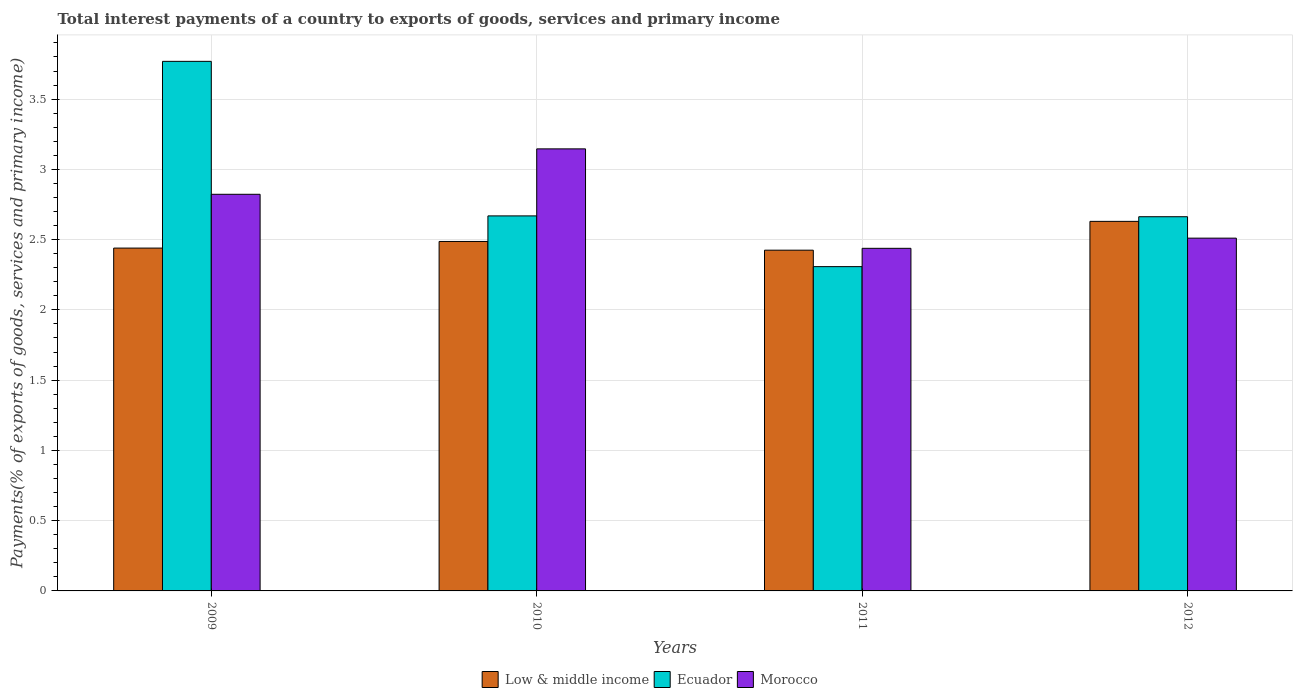Are the number of bars on each tick of the X-axis equal?
Offer a very short reply. Yes. In how many cases, is the number of bars for a given year not equal to the number of legend labels?
Ensure brevity in your answer.  0. What is the total interest payments in Ecuador in 2009?
Provide a short and direct response. 3.77. Across all years, what is the maximum total interest payments in Low & middle income?
Offer a terse response. 2.63. Across all years, what is the minimum total interest payments in Low & middle income?
Provide a short and direct response. 2.42. In which year was the total interest payments in Morocco minimum?
Provide a succinct answer. 2011. What is the total total interest payments in Low & middle income in the graph?
Your answer should be very brief. 9.98. What is the difference between the total interest payments in Morocco in 2011 and that in 2012?
Your answer should be compact. -0.07. What is the difference between the total interest payments in Ecuador in 2011 and the total interest payments in Morocco in 2012?
Your response must be concise. -0.2. What is the average total interest payments in Ecuador per year?
Your response must be concise. 2.85. In the year 2011, what is the difference between the total interest payments in Ecuador and total interest payments in Morocco?
Provide a short and direct response. -0.13. What is the ratio of the total interest payments in Ecuador in 2009 to that in 2012?
Your answer should be very brief. 1.42. Is the difference between the total interest payments in Ecuador in 2009 and 2012 greater than the difference between the total interest payments in Morocco in 2009 and 2012?
Provide a succinct answer. Yes. What is the difference between the highest and the second highest total interest payments in Ecuador?
Ensure brevity in your answer.  1.1. What is the difference between the highest and the lowest total interest payments in Ecuador?
Ensure brevity in your answer.  1.46. In how many years, is the total interest payments in Ecuador greater than the average total interest payments in Ecuador taken over all years?
Offer a very short reply. 1. What does the 2nd bar from the left in 2009 represents?
Provide a succinct answer. Ecuador. What does the 1st bar from the right in 2009 represents?
Provide a short and direct response. Morocco. How many years are there in the graph?
Your answer should be compact. 4. Are the values on the major ticks of Y-axis written in scientific E-notation?
Your answer should be very brief. No. Where does the legend appear in the graph?
Your answer should be very brief. Bottom center. What is the title of the graph?
Your response must be concise. Total interest payments of a country to exports of goods, services and primary income. Does "South Sudan" appear as one of the legend labels in the graph?
Provide a succinct answer. No. What is the label or title of the Y-axis?
Make the answer very short. Payments(% of exports of goods, services and primary income). What is the Payments(% of exports of goods, services and primary income) of Low & middle income in 2009?
Make the answer very short. 2.44. What is the Payments(% of exports of goods, services and primary income) in Ecuador in 2009?
Your response must be concise. 3.77. What is the Payments(% of exports of goods, services and primary income) of Morocco in 2009?
Offer a terse response. 2.82. What is the Payments(% of exports of goods, services and primary income) in Low & middle income in 2010?
Give a very brief answer. 2.49. What is the Payments(% of exports of goods, services and primary income) of Ecuador in 2010?
Your response must be concise. 2.67. What is the Payments(% of exports of goods, services and primary income) in Morocco in 2010?
Offer a terse response. 3.15. What is the Payments(% of exports of goods, services and primary income) in Low & middle income in 2011?
Give a very brief answer. 2.42. What is the Payments(% of exports of goods, services and primary income) of Ecuador in 2011?
Make the answer very short. 2.31. What is the Payments(% of exports of goods, services and primary income) in Morocco in 2011?
Your answer should be very brief. 2.44. What is the Payments(% of exports of goods, services and primary income) of Low & middle income in 2012?
Provide a succinct answer. 2.63. What is the Payments(% of exports of goods, services and primary income) in Ecuador in 2012?
Your answer should be very brief. 2.66. What is the Payments(% of exports of goods, services and primary income) in Morocco in 2012?
Provide a short and direct response. 2.51. Across all years, what is the maximum Payments(% of exports of goods, services and primary income) of Low & middle income?
Keep it short and to the point. 2.63. Across all years, what is the maximum Payments(% of exports of goods, services and primary income) of Ecuador?
Your answer should be very brief. 3.77. Across all years, what is the maximum Payments(% of exports of goods, services and primary income) of Morocco?
Make the answer very short. 3.15. Across all years, what is the minimum Payments(% of exports of goods, services and primary income) in Low & middle income?
Your answer should be very brief. 2.42. Across all years, what is the minimum Payments(% of exports of goods, services and primary income) in Ecuador?
Keep it short and to the point. 2.31. Across all years, what is the minimum Payments(% of exports of goods, services and primary income) of Morocco?
Provide a succinct answer. 2.44. What is the total Payments(% of exports of goods, services and primary income) in Low & middle income in the graph?
Your answer should be compact. 9.98. What is the total Payments(% of exports of goods, services and primary income) of Ecuador in the graph?
Offer a very short reply. 11.41. What is the total Payments(% of exports of goods, services and primary income) of Morocco in the graph?
Your answer should be compact. 10.92. What is the difference between the Payments(% of exports of goods, services and primary income) of Low & middle income in 2009 and that in 2010?
Offer a very short reply. -0.05. What is the difference between the Payments(% of exports of goods, services and primary income) in Ecuador in 2009 and that in 2010?
Your answer should be very brief. 1.1. What is the difference between the Payments(% of exports of goods, services and primary income) of Morocco in 2009 and that in 2010?
Give a very brief answer. -0.32. What is the difference between the Payments(% of exports of goods, services and primary income) of Low & middle income in 2009 and that in 2011?
Your answer should be very brief. 0.01. What is the difference between the Payments(% of exports of goods, services and primary income) in Ecuador in 2009 and that in 2011?
Provide a succinct answer. 1.46. What is the difference between the Payments(% of exports of goods, services and primary income) in Morocco in 2009 and that in 2011?
Your answer should be compact. 0.38. What is the difference between the Payments(% of exports of goods, services and primary income) in Low & middle income in 2009 and that in 2012?
Your answer should be compact. -0.19. What is the difference between the Payments(% of exports of goods, services and primary income) of Ecuador in 2009 and that in 2012?
Make the answer very short. 1.11. What is the difference between the Payments(% of exports of goods, services and primary income) in Morocco in 2009 and that in 2012?
Your response must be concise. 0.31. What is the difference between the Payments(% of exports of goods, services and primary income) in Low & middle income in 2010 and that in 2011?
Provide a succinct answer. 0.06. What is the difference between the Payments(% of exports of goods, services and primary income) of Ecuador in 2010 and that in 2011?
Give a very brief answer. 0.36. What is the difference between the Payments(% of exports of goods, services and primary income) in Morocco in 2010 and that in 2011?
Make the answer very short. 0.71. What is the difference between the Payments(% of exports of goods, services and primary income) of Low & middle income in 2010 and that in 2012?
Make the answer very short. -0.14. What is the difference between the Payments(% of exports of goods, services and primary income) of Ecuador in 2010 and that in 2012?
Your answer should be compact. 0.01. What is the difference between the Payments(% of exports of goods, services and primary income) in Morocco in 2010 and that in 2012?
Make the answer very short. 0.64. What is the difference between the Payments(% of exports of goods, services and primary income) in Low & middle income in 2011 and that in 2012?
Offer a terse response. -0.2. What is the difference between the Payments(% of exports of goods, services and primary income) in Ecuador in 2011 and that in 2012?
Provide a short and direct response. -0.36. What is the difference between the Payments(% of exports of goods, services and primary income) of Morocco in 2011 and that in 2012?
Provide a succinct answer. -0.07. What is the difference between the Payments(% of exports of goods, services and primary income) in Low & middle income in 2009 and the Payments(% of exports of goods, services and primary income) in Ecuador in 2010?
Offer a very short reply. -0.23. What is the difference between the Payments(% of exports of goods, services and primary income) of Low & middle income in 2009 and the Payments(% of exports of goods, services and primary income) of Morocco in 2010?
Give a very brief answer. -0.71. What is the difference between the Payments(% of exports of goods, services and primary income) in Ecuador in 2009 and the Payments(% of exports of goods, services and primary income) in Morocco in 2010?
Your answer should be very brief. 0.62. What is the difference between the Payments(% of exports of goods, services and primary income) in Low & middle income in 2009 and the Payments(% of exports of goods, services and primary income) in Ecuador in 2011?
Your answer should be very brief. 0.13. What is the difference between the Payments(% of exports of goods, services and primary income) of Low & middle income in 2009 and the Payments(% of exports of goods, services and primary income) of Morocco in 2011?
Keep it short and to the point. 0. What is the difference between the Payments(% of exports of goods, services and primary income) in Ecuador in 2009 and the Payments(% of exports of goods, services and primary income) in Morocco in 2011?
Offer a very short reply. 1.33. What is the difference between the Payments(% of exports of goods, services and primary income) in Low & middle income in 2009 and the Payments(% of exports of goods, services and primary income) in Ecuador in 2012?
Ensure brevity in your answer.  -0.22. What is the difference between the Payments(% of exports of goods, services and primary income) of Low & middle income in 2009 and the Payments(% of exports of goods, services and primary income) of Morocco in 2012?
Your response must be concise. -0.07. What is the difference between the Payments(% of exports of goods, services and primary income) in Ecuador in 2009 and the Payments(% of exports of goods, services and primary income) in Morocco in 2012?
Make the answer very short. 1.26. What is the difference between the Payments(% of exports of goods, services and primary income) of Low & middle income in 2010 and the Payments(% of exports of goods, services and primary income) of Ecuador in 2011?
Offer a very short reply. 0.18. What is the difference between the Payments(% of exports of goods, services and primary income) in Low & middle income in 2010 and the Payments(% of exports of goods, services and primary income) in Morocco in 2011?
Your answer should be compact. 0.05. What is the difference between the Payments(% of exports of goods, services and primary income) of Ecuador in 2010 and the Payments(% of exports of goods, services and primary income) of Morocco in 2011?
Offer a terse response. 0.23. What is the difference between the Payments(% of exports of goods, services and primary income) of Low & middle income in 2010 and the Payments(% of exports of goods, services and primary income) of Ecuador in 2012?
Your response must be concise. -0.18. What is the difference between the Payments(% of exports of goods, services and primary income) in Low & middle income in 2010 and the Payments(% of exports of goods, services and primary income) in Morocco in 2012?
Offer a very short reply. -0.02. What is the difference between the Payments(% of exports of goods, services and primary income) of Ecuador in 2010 and the Payments(% of exports of goods, services and primary income) of Morocco in 2012?
Your answer should be compact. 0.16. What is the difference between the Payments(% of exports of goods, services and primary income) of Low & middle income in 2011 and the Payments(% of exports of goods, services and primary income) of Ecuador in 2012?
Keep it short and to the point. -0.24. What is the difference between the Payments(% of exports of goods, services and primary income) in Low & middle income in 2011 and the Payments(% of exports of goods, services and primary income) in Morocco in 2012?
Provide a succinct answer. -0.09. What is the difference between the Payments(% of exports of goods, services and primary income) of Ecuador in 2011 and the Payments(% of exports of goods, services and primary income) of Morocco in 2012?
Make the answer very short. -0.2. What is the average Payments(% of exports of goods, services and primary income) of Low & middle income per year?
Provide a short and direct response. 2.5. What is the average Payments(% of exports of goods, services and primary income) in Ecuador per year?
Make the answer very short. 2.85. What is the average Payments(% of exports of goods, services and primary income) of Morocco per year?
Make the answer very short. 2.73. In the year 2009, what is the difference between the Payments(% of exports of goods, services and primary income) of Low & middle income and Payments(% of exports of goods, services and primary income) of Ecuador?
Keep it short and to the point. -1.33. In the year 2009, what is the difference between the Payments(% of exports of goods, services and primary income) of Low & middle income and Payments(% of exports of goods, services and primary income) of Morocco?
Your answer should be very brief. -0.38. In the year 2009, what is the difference between the Payments(% of exports of goods, services and primary income) of Ecuador and Payments(% of exports of goods, services and primary income) of Morocco?
Your answer should be compact. 0.95. In the year 2010, what is the difference between the Payments(% of exports of goods, services and primary income) of Low & middle income and Payments(% of exports of goods, services and primary income) of Ecuador?
Give a very brief answer. -0.18. In the year 2010, what is the difference between the Payments(% of exports of goods, services and primary income) of Low & middle income and Payments(% of exports of goods, services and primary income) of Morocco?
Your answer should be compact. -0.66. In the year 2010, what is the difference between the Payments(% of exports of goods, services and primary income) in Ecuador and Payments(% of exports of goods, services and primary income) in Morocco?
Offer a very short reply. -0.48. In the year 2011, what is the difference between the Payments(% of exports of goods, services and primary income) of Low & middle income and Payments(% of exports of goods, services and primary income) of Ecuador?
Your answer should be compact. 0.12. In the year 2011, what is the difference between the Payments(% of exports of goods, services and primary income) in Low & middle income and Payments(% of exports of goods, services and primary income) in Morocco?
Give a very brief answer. -0.01. In the year 2011, what is the difference between the Payments(% of exports of goods, services and primary income) in Ecuador and Payments(% of exports of goods, services and primary income) in Morocco?
Provide a short and direct response. -0.13. In the year 2012, what is the difference between the Payments(% of exports of goods, services and primary income) of Low & middle income and Payments(% of exports of goods, services and primary income) of Ecuador?
Keep it short and to the point. -0.03. In the year 2012, what is the difference between the Payments(% of exports of goods, services and primary income) in Low & middle income and Payments(% of exports of goods, services and primary income) in Morocco?
Give a very brief answer. 0.12. In the year 2012, what is the difference between the Payments(% of exports of goods, services and primary income) of Ecuador and Payments(% of exports of goods, services and primary income) of Morocco?
Provide a short and direct response. 0.15. What is the ratio of the Payments(% of exports of goods, services and primary income) of Ecuador in 2009 to that in 2010?
Your answer should be very brief. 1.41. What is the ratio of the Payments(% of exports of goods, services and primary income) of Morocco in 2009 to that in 2010?
Your response must be concise. 0.9. What is the ratio of the Payments(% of exports of goods, services and primary income) of Low & middle income in 2009 to that in 2011?
Offer a terse response. 1.01. What is the ratio of the Payments(% of exports of goods, services and primary income) of Ecuador in 2009 to that in 2011?
Offer a terse response. 1.63. What is the ratio of the Payments(% of exports of goods, services and primary income) in Morocco in 2009 to that in 2011?
Give a very brief answer. 1.16. What is the ratio of the Payments(% of exports of goods, services and primary income) of Low & middle income in 2009 to that in 2012?
Your answer should be very brief. 0.93. What is the ratio of the Payments(% of exports of goods, services and primary income) of Ecuador in 2009 to that in 2012?
Keep it short and to the point. 1.42. What is the ratio of the Payments(% of exports of goods, services and primary income) in Morocco in 2009 to that in 2012?
Ensure brevity in your answer.  1.12. What is the ratio of the Payments(% of exports of goods, services and primary income) of Low & middle income in 2010 to that in 2011?
Your answer should be compact. 1.03. What is the ratio of the Payments(% of exports of goods, services and primary income) of Ecuador in 2010 to that in 2011?
Ensure brevity in your answer.  1.16. What is the ratio of the Payments(% of exports of goods, services and primary income) in Morocco in 2010 to that in 2011?
Offer a very short reply. 1.29. What is the ratio of the Payments(% of exports of goods, services and primary income) in Low & middle income in 2010 to that in 2012?
Keep it short and to the point. 0.95. What is the ratio of the Payments(% of exports of goods, services and primary income) in Morocco in 2010 to that in 2012?
Your answer should be very brief. 1.25. What is the ratio of the Payments(% of exports of goods, services and primary income) of Low & middle income in 2011 to that in 2012?
Keep it short and to the point. 0.92. What is the ratio of the Payments(% of exports of goods, services and primary income) of Ecuador in 2011 to that in 2012?
Your answer should be very brief. 0.87. What is the ratio of the Payments(% of exports of goods, services and primary income) in Morocco in 2011 to that in 2012?
Ensure brevity in your answer.  0.97. What is the difference between the highest and the second highest Payments(% of exports of goods, services and primary income) in Low & middle income?
Provide a short and direct response. 0.14. What is the difference between the highest and the second highest Payments(% of exports of goods, services and primary income) in Ecuador?
Your answer should be very brief. 1.1. What is the difference between the highest and the second highest Payments(% of exports of goods, services and primary income) of Morocco?
Your answer should be compact. 0.32. What is the difference between the highest and the lowest Payments(% of exports of goods, services and primary income) in Low & middle income?
Offer a very short reply. 0.2. What is the difference between the highest and the lowest Payments(% of exports of goods, services and primary income) of Ecuador?
Give a very brief answer. 1.46. What is the difference between the highest and the lowest Payments(% of exports of goods, services and primary income) in Morocco?
Provide a succinct answer. 0.71. 